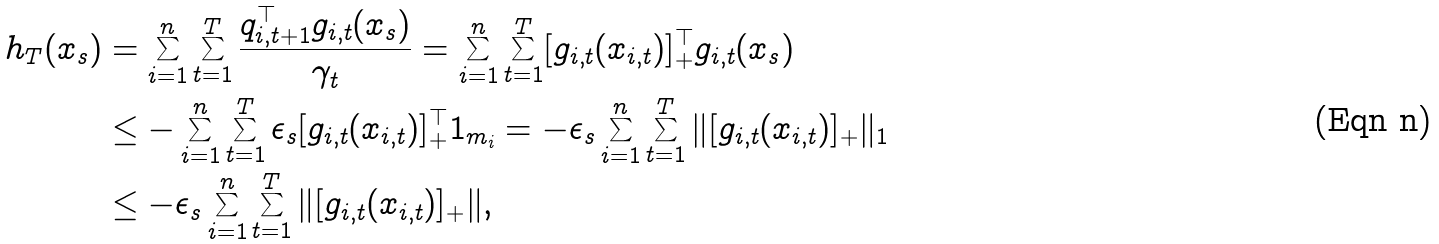Convert formula to latex. <formula><loc_0><loc_0><loc_500><loc_500>h _ { T } ( x _ { s } ) & = \sum _ { i = 1 } ^ { n } \sum _ { t = 1 } ^ { T } \frac { q _ { i , t + 1 } ^ { \top } g _ { i , t } ( x _ { s } ) } { \gamma _ { t } } = \sum _ { i = 1 } ^ { n } \sum _ { t = 1 } ^ { T } [ g _ { i , t } ( x _ { i , t } ) ] _ { + } ^ { \top } g _ { i , t } ( x _ { s } ) \\ & \leq - \sum _ { i = 1 } ^ { n } \sum _ { t = 1 } ^ { T } \epsilon _ { s } [ g _ { i , t } ( x _ { i , t } ) ] _ { + } ^ { \top } { 1 } _ { m _ { i } } = - \epsilon _ { s } \sum _ { i = 1 } ^ { n } \sum _ { t = 1 } ^ { T } \| [ g _ { i , t } ( x _ { i , t } ) ] _ { + } \| _ { 1 } \\ & \leq - \epsilon _ { s } \sum _ { i = 1 } ^ { n } \sum _ { t = 1 } ^ { T } \| [ g _ { i , t } ( x _ { i , t } ) ] _ { + } \| ,</formula> 